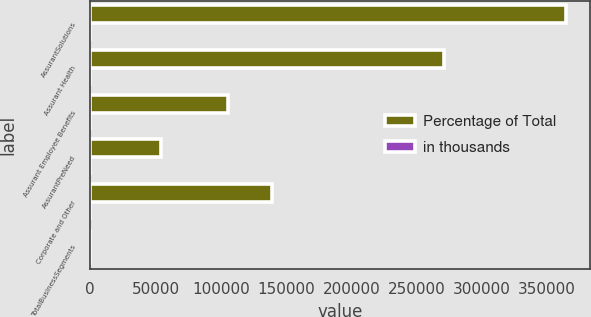Convert chart to OTSL. <chart><loc_0><loc_0><loc_500><loc_500><stacked_bar_chart><ecel><fcel>AssurantSolutions<fcel>Assurant Health<fcel>Assurant Employee Benefits<fcel>AssurantPreNeed<fcel>Corporate and Other<fcel>TotalBusinessSegments<nl><fcel>Percentage of Total<fcel>364398<fcel>270842<fcel>105564<fcel>54091<fcel>139287<fcel>100<nl><fcel>in thousands<fcel>56<fcel>41<fcel>16<fcel>8<fcel>21<fcel>100<nl></chart> 